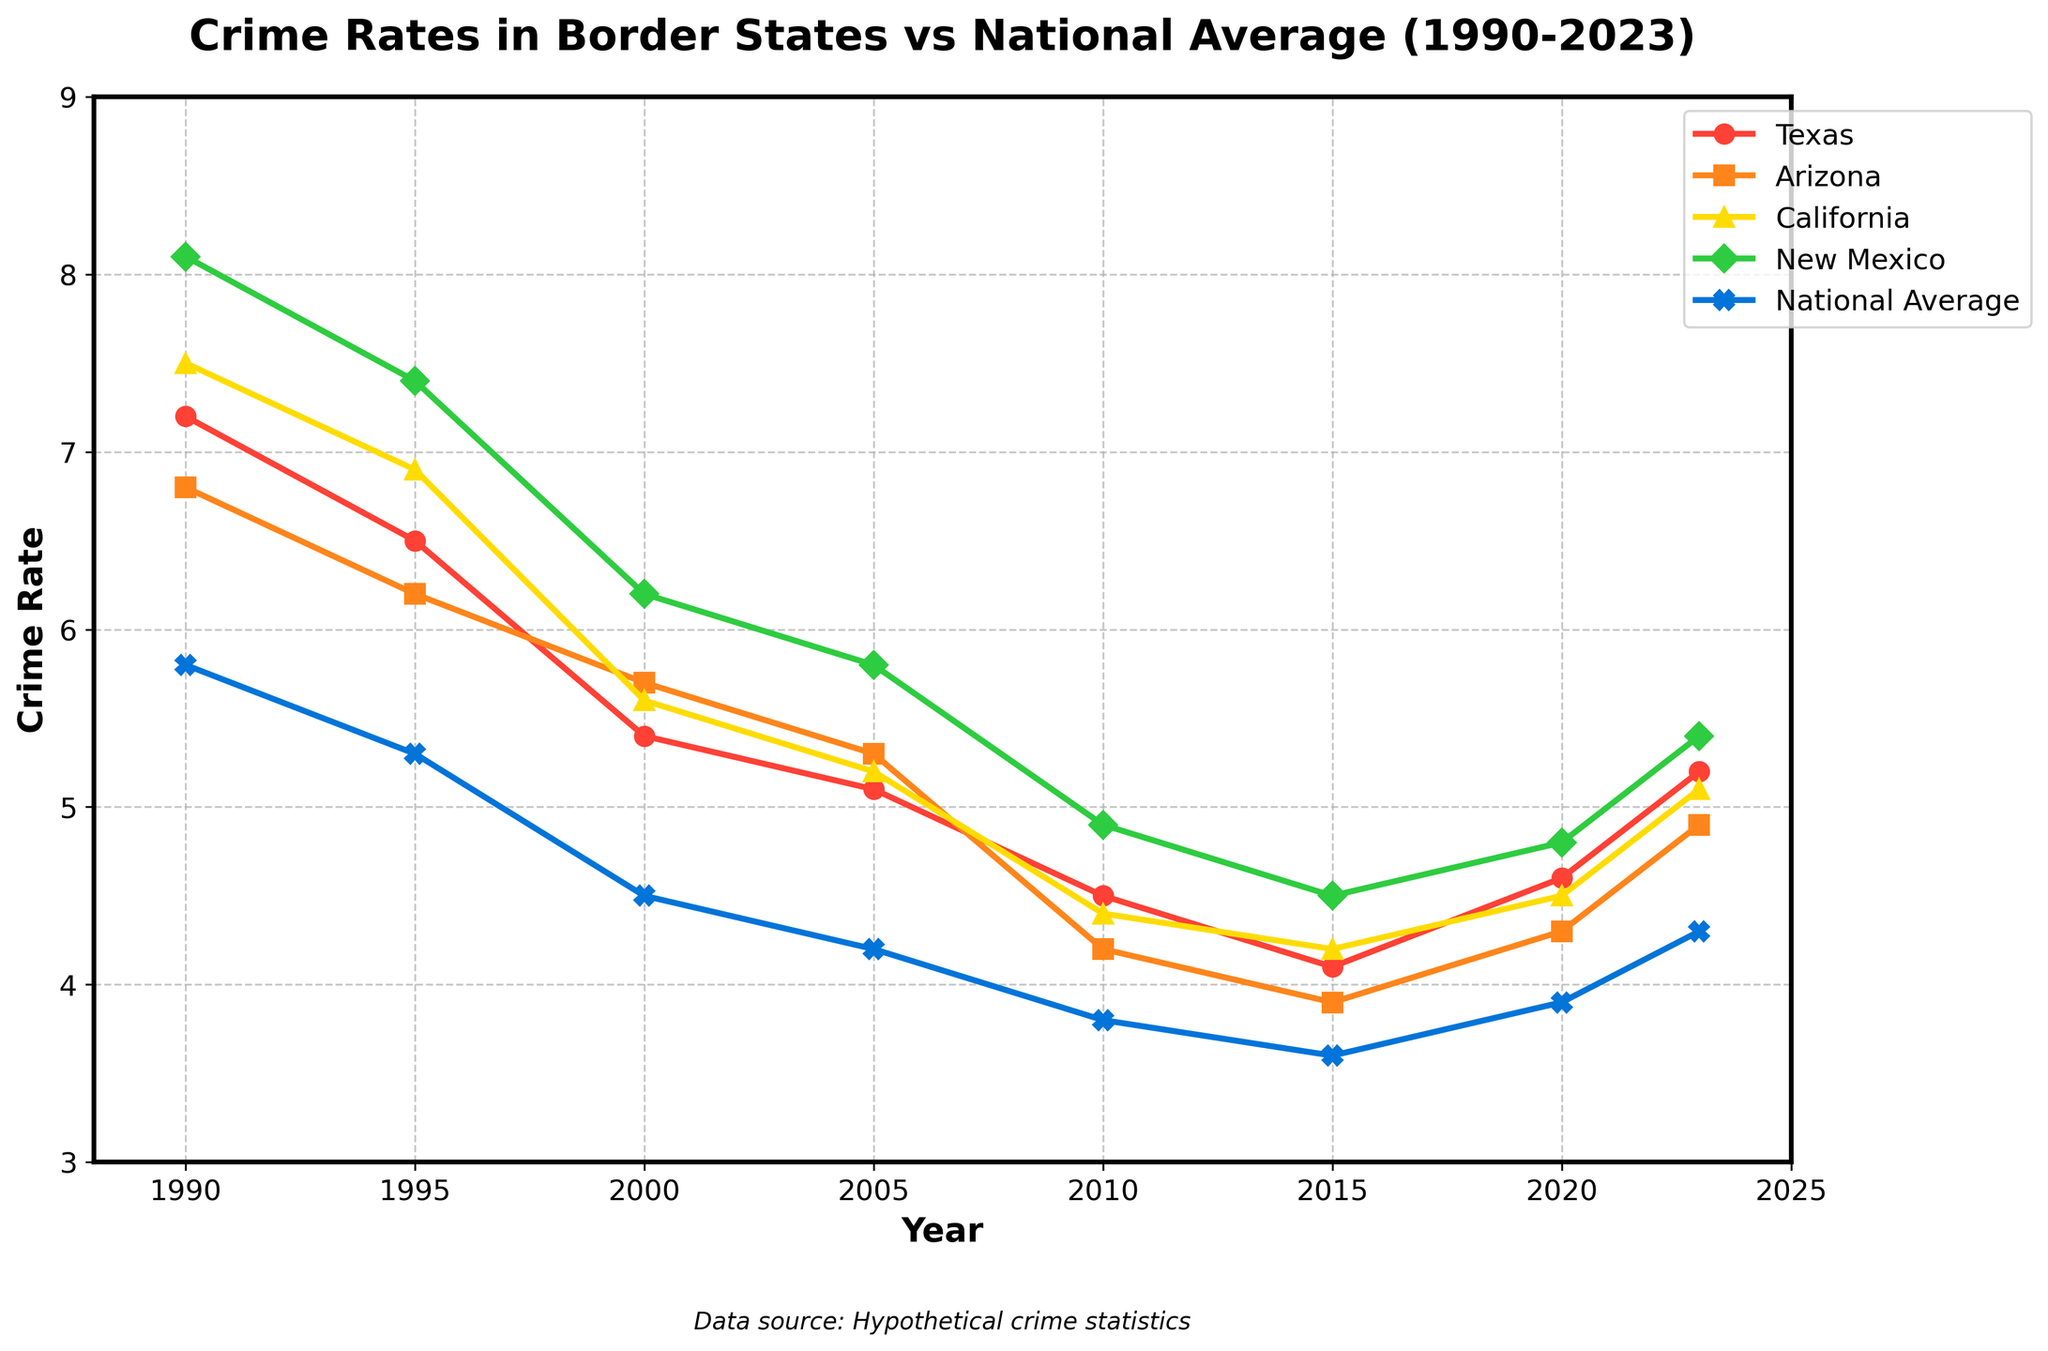What is the crime rate trend for Texas from 1990 to 2023? From the figure, the crime rate in Texas starts at 7.2 in 1990, decreases almost consistently over the years, dropping as low as 4.1 in 2015, but then starts to rise again, reaching 5.2 in 2023.
Answer: Decreasing initially, then rising after 2015 Which state had the highest crime rate in 1995? By observing the points plotted for each state in 1995, New Mexico has the highest crime rate of 7.4.
Answer: New Mexico In 2023, which state's crime rate is closest to the national average? From the figure, in 2023 the national average is 4.3. Arizona has a crime rate of 4.9, which is the closest to this.
Answer: Arizona How does Arizona's crime rate in 2000 compare with California's in 2000? By looking at the plot points, Arizona's crime rate in 2000 is 5.7, while California's is 5.6. Thus, Arizona's rate is slightly higher.
Answer: Arizona's rate is slightly higher What is the overall trend in the national average crime rate from 1990 to 2023? Observing the national average line, it consistently decreases from 5.8 in 1990 to 3.6 in 2015, then rises slightly to 4.3 by 2023.
Answer: Decreasing initially, then rising after 2015 By how much did the crime rate in New Mexico change from 1990 to 2000? New Mexico's crime rate in 1990 is 8.1 and in 2000 is 6.2. The change is 8.1 - 6.2 = 1.9.
Answer: Decreased by 1.9 Which state had the lowest crime rate in 2010? From the figure, Arizona has the lowest crime rate in 2010 at 4.2.
Answer: Arizona How does the crime rate change in Texas from 2010 to 2020? Texas' crime rate in 2010 is 4.5 and in 2020 it is 4.6. The change is 4.6 - 4.5 = 0.1.
Answer: Increased by 0.1 What was the overall difference between the highest crime rate in New Mexico and the lowest crime rate in Arizona across the entire period? The highest crime rate in New Mexico is 8.1 in 1990, and the lowest in Arizona is 3.9 in 2015. The difference is 8.1 - 3.9 = 4.2.
Answer: Difference is 4.2 